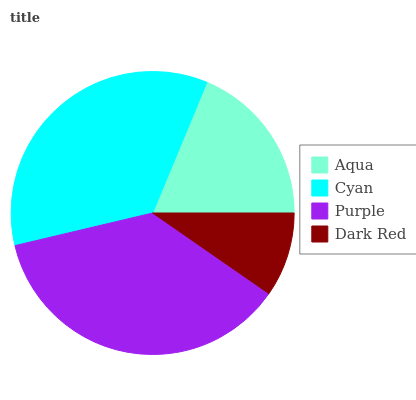Is Dark Red the minimum?
Answer yes or no. Yes. Is Purple the maximum?
Answer yes or no. Yes. Is Cyan the minimum?
Answer yes or no. No. Is Cyan the maximum?
Answer yes or no. No. Is Cyan greater than Aqua?
Answer yes or no. Yes. Is Aqua less than Cyan?
Answer yes or no. Yes. Is Aqua greater than Cyan?
Answer yes or no. No. Is Cyan less than Aqua?
Answer yes or no. No. Is Cyan the high median?
Answer yes or no. Yes. Is Aqua the low median?
Answer yes or no. Yes. Is Dark Red the high median?
Answer yes or no. No. Is Purple the low median?
Answer yes or no. No. 